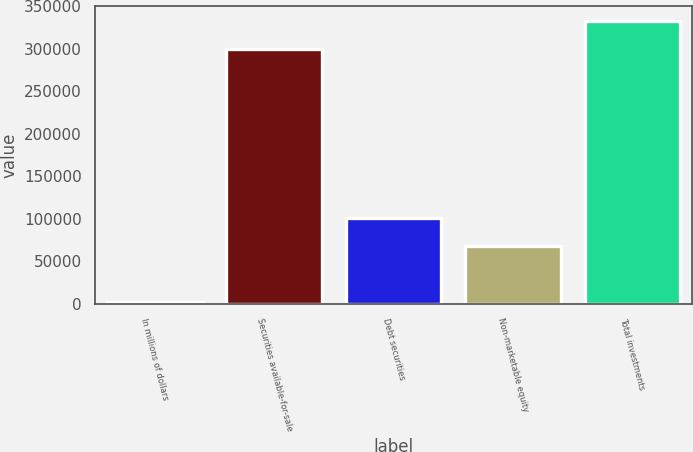<chart> <loc_0><loc_0><loc_500><loc_500><bar_chart><fcel>In millions of dollars<fcel>Securities available-for-sale<fcel>Debt securities<fcel>Non-marketable equity<fcel>Total investments<nl><fcel>2014<fcel>300143<fcel>101443<fcel>68299.8<fcel>333443<nl></chart> 